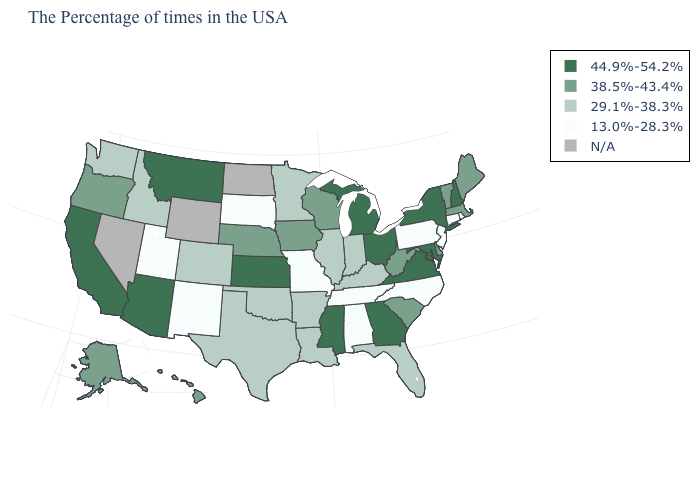What is the value of South Carolina?
Answer briefly. 38.5%-43.4%. What is the value of Iowa?
Quick response, please. 38.5%-43.4%. Is the legend a continuous bar?
Answer briefly. No. Which states have the highest value in the USA?
Quick response, please. New Hampshire, New York, Maryland, Virginia, Ohio, Georgia, Michigan, Mississippi, Kansas, Montana, Arizona, California. What is the lowest value in the USA?
Quick response, please. 13.0%-28.3%. Among the states that border Kansas , does Colorado have the highest value?
Concise answer only. No. Which states hav the highest value in the Northeast?
Concise answer only. New Hampshire, New York. Does the first symbol in the legend represent the smallest category?
Quick response, please. No. Name the states that have a value in the range N/A?
Give a very brief answer. North Dakota, Wyoming, Nevada. What is the highest value in the USA?
Write a very short answer. 44.9%-54.2%. What is the highest value in states that border Illinois?
Write a very short answer. 38.5%-43.4%. Among the states that border Tennessee , which have the lowest value?
Concise answer only. North Carolina, Alabama, Missouri. What is the lowest value in the Northeast?
Concise answer only. 13.0%-28.3%. 